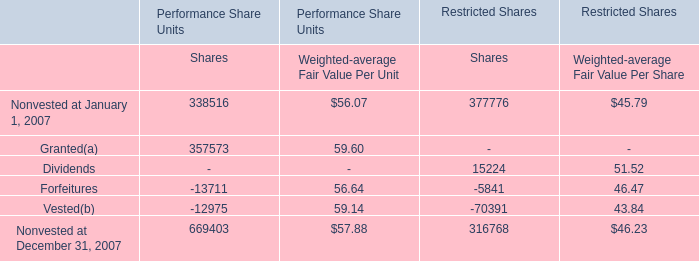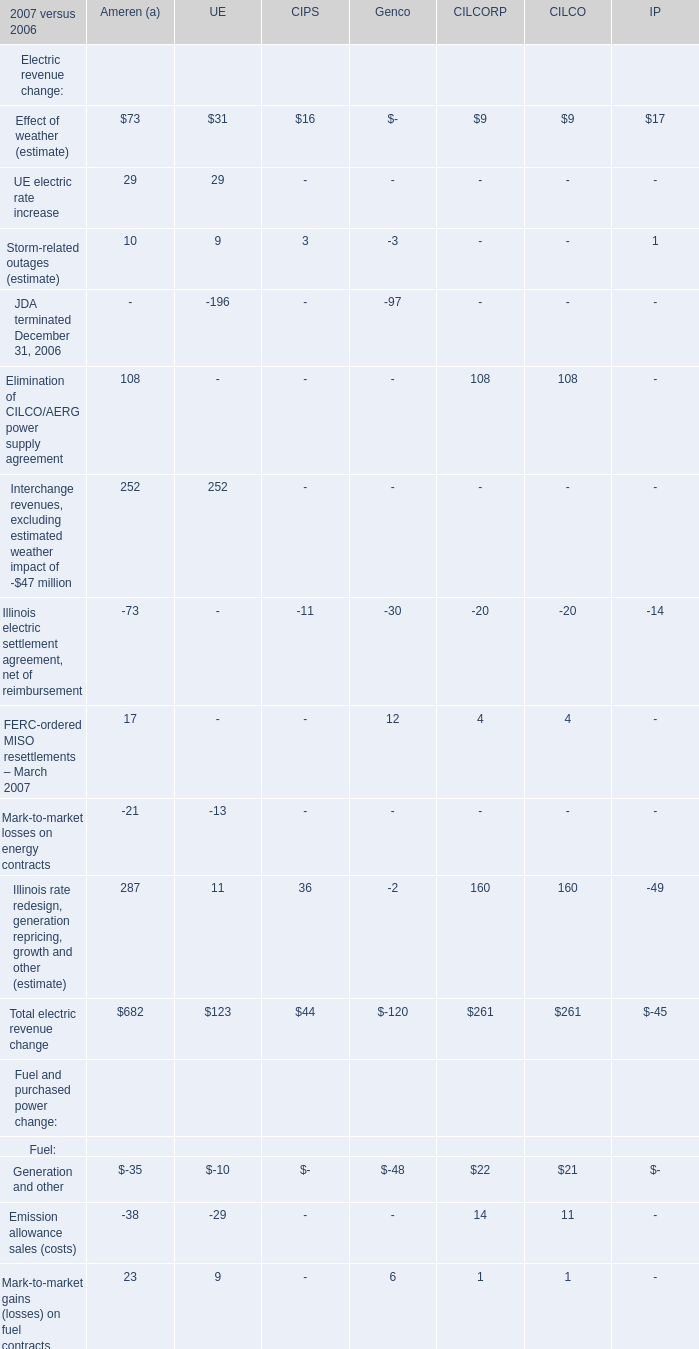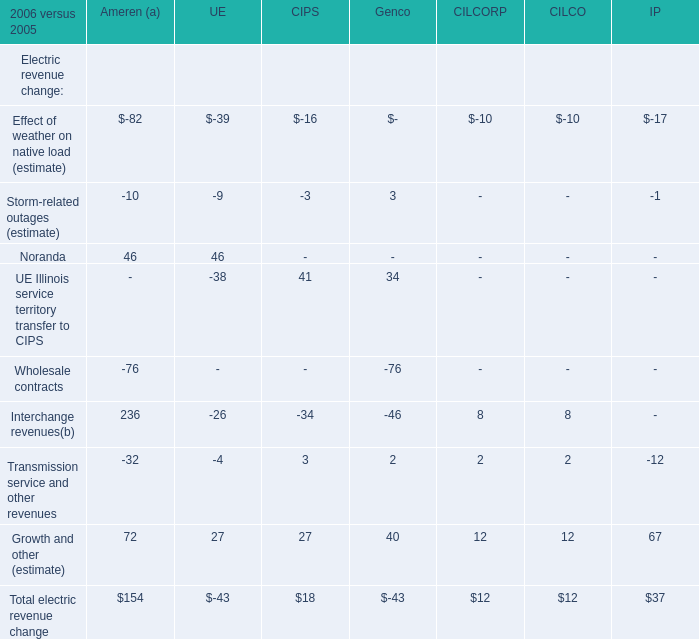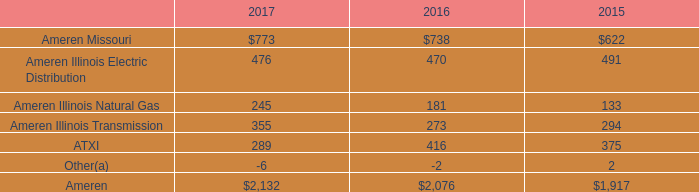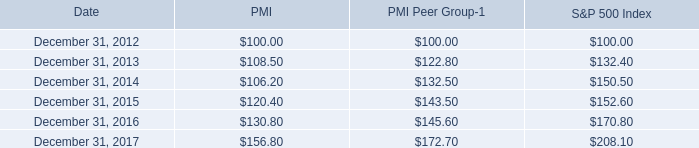what is the growth rate in pmi's share price from 2014 to 2015? 
Computations: ((120.40 - 106.20) / 106.20)
Answer: 0.13371. 